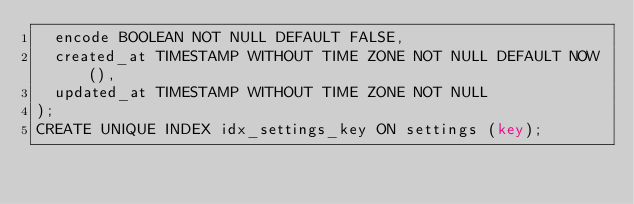<code> <loc_0><loc_0><loc_500><loc_500><_SQL_>  encode BOOLEAN NOT NULL DEFAULT FALSE,
  created_at TIMESTAMP WITHOUT TIME ZONE NOT NULL DEFAULT NOW(),
  updated_at TIMESTAMP WITHOUT TIME ZONE NOT NULL
);
CREATE UNIQUE INDEX idx_settings_key ON settings (key);
</code> 